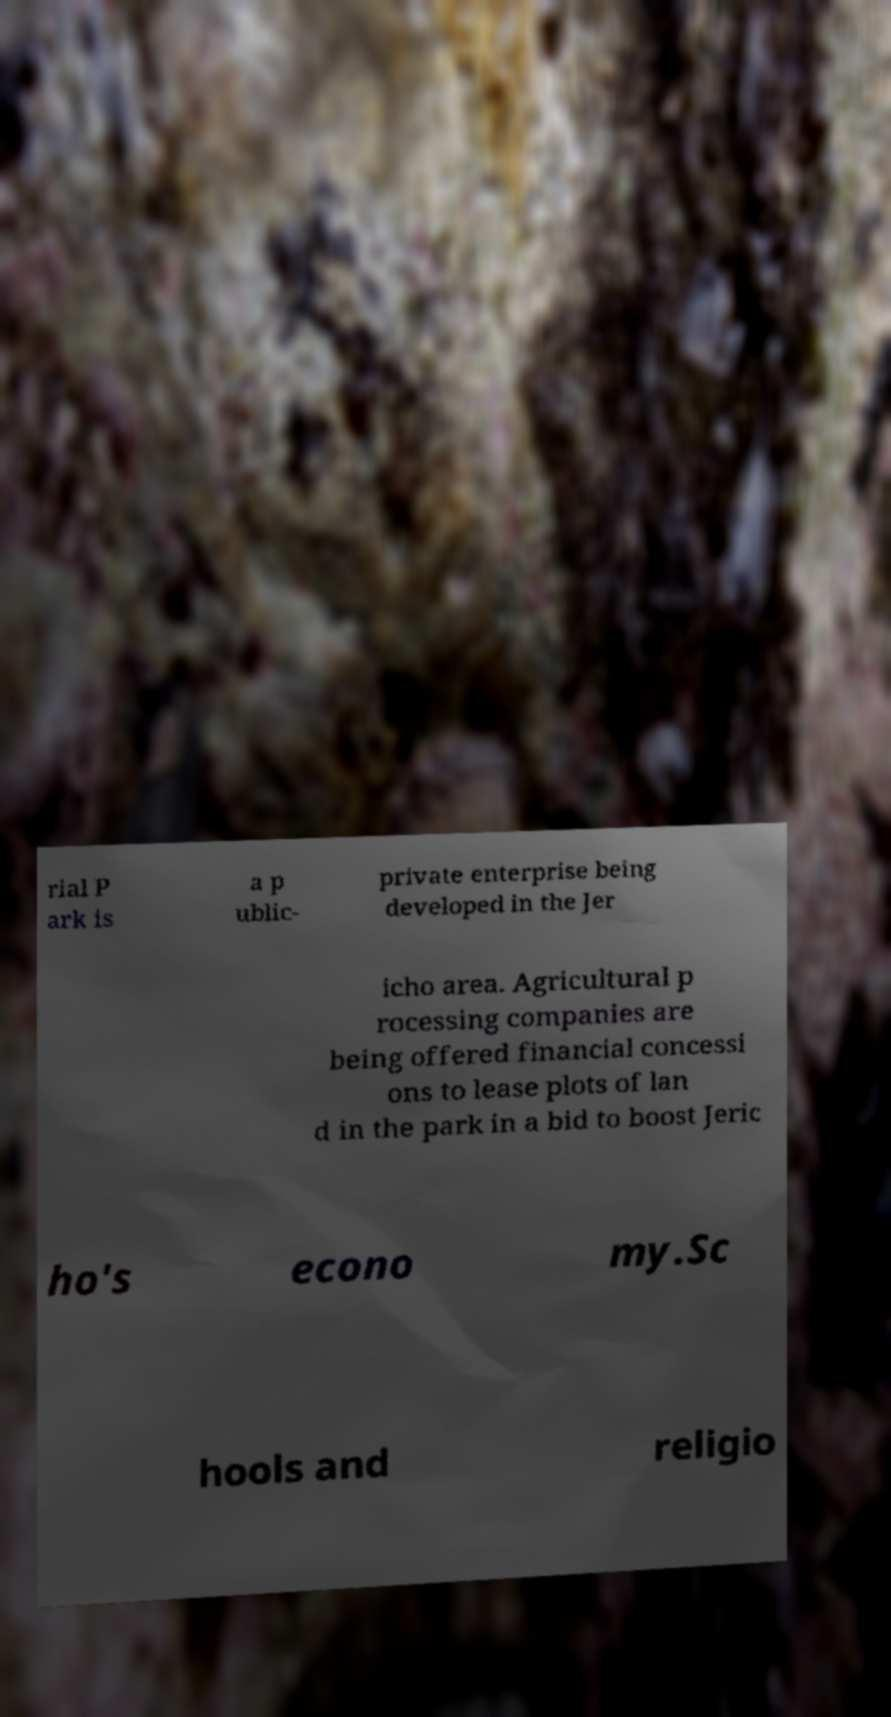Please identify and transcribe the text found in this image. rial P ark is a p ublic- private enterprise being developed in the Jer icho area. Agricultural p rocessing companies are being offered financial concessi ons to lease plots of lan d in the park in a bid to boost Jeric ho's econo my.Sc hools and religio 